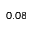Convert formula to latex. <formula><loc_0><loc_0><loc_500><loc_500>0 . 0 8</formula> 